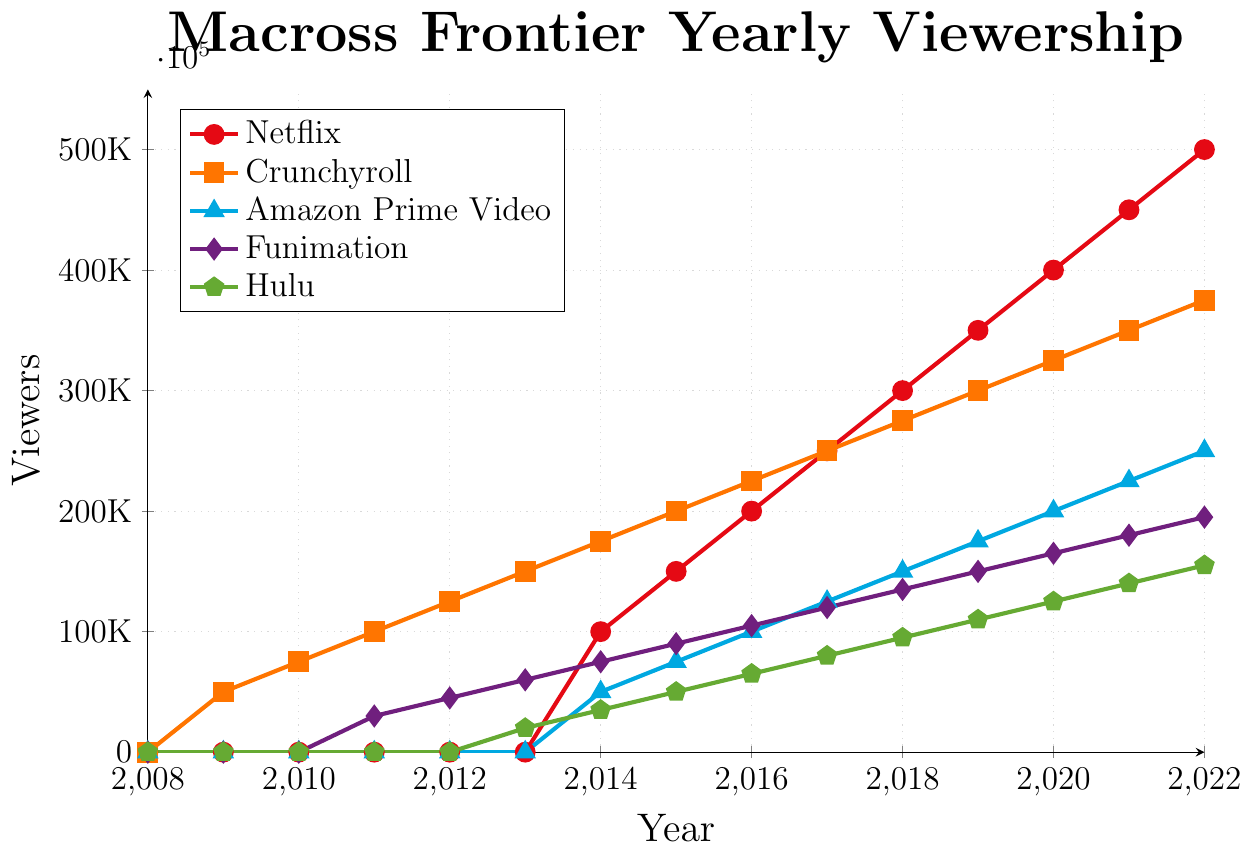What year did Crunchyroll's viewership surpass 100,000? Look at the Crunchyroll data points (orange squares) on the chart. Crunchyroll surpassed 100,000 viewers in 2011.
Answer: 2011 Which platform had the highest viewership in 2022? Compare the data points for all platforms in 2022. Netflix had the highest viewership with 500,000 viewers.
Answer: Netflix By how much did Netflix's viewership grow from 2014 to 2018? Netflix's viewership in 2014 was 100,000 and in 2018 it was 300,000. The growth is 300,000 - 100,000 = 200,000.
Answer: 200,000 Which platform had the smallest increase in viewership from 2011 to 2012? Compare the increases for each platform from 2011 to 2012. Hulu had no viewers in both years, while Funimation increased by 15,000 (from 30,000 to 45,000). Funimation had the smallest increase.
Answer: Funimation How did Amazon Prime Video's viewership change between 2014 and 2015? Look at Amazon Prime Video's viewership in 2014 (50,000) and in 2015 (75,000). The change is 75,000 - 50,000 = 25,000.
Answer: Increased by 25,000 Which platform showed the most consistent yearly increase in viewership? Examine the yearly increments for each platform. Crunchyroll shows a consistent yearly increase of 25,000 viewers each year.
Answer: Crunchyroll How many viewers did Hulu gain from 2013 to 2020? Hulu's viewers in 2013 were 20,000 and in 2020 were 125,000. The gain is 125,000 - 20,000 = 105,000.
Answer: 105,000 Which two platforms had equal viewership in 2017? Examine the 2017 viewership for all platforms. Netflix and Crunchyroll both had 250,000 viewers in 2017.
Answer: Netflix and Crunchyroll From which year did Netflix start having viewership data in the chart? Identify the first non-zero data point for Netflix. Netflix started having viewership data in 2014.
Answer: 2014 Which platform had the steepest viewership increase from 2011 to 2012? Compare the steepest slopes in the chart between 2011 and 2012. Crunchyroll showed the steepest increase with a gain of 25,000 (from 100,000 to 125,000).
Answer: Crunchyroll 